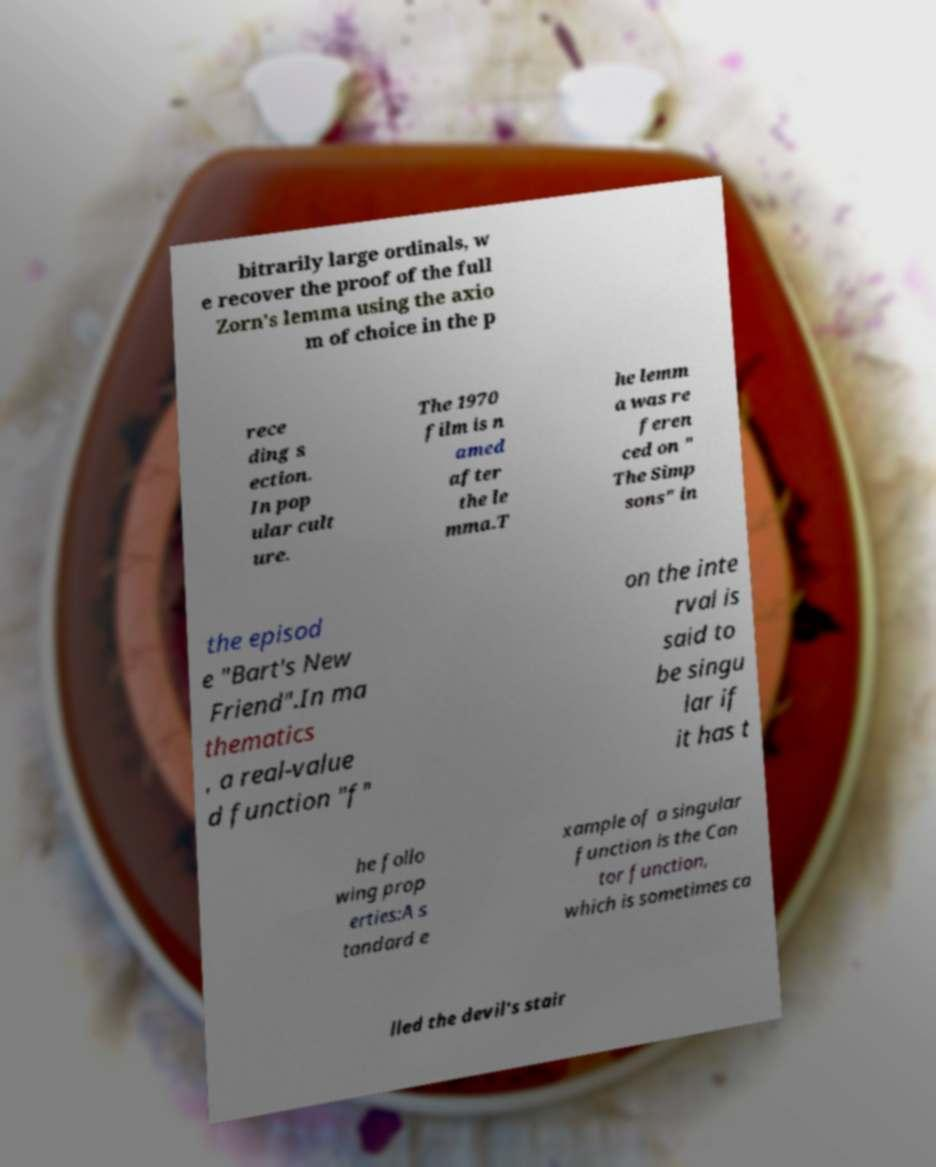Could you extract and type out the text from this image? bitrarily large ordinals, w e recover the proof of the full Zorn's lemma using the axio m of choice in the p rece ding s ection. In pop ular cult ure. The 1970 film is n amed after the le mma.T he lemm a was re feren ced on " The Simp sons" in the episod e "Bart's New Friend".In ma thematics , a real-value d function "f" on the inte rval is said to be singu lar if it has t he follo wing prop erties:A s tandard e xample of a singular function is the Can tor function, which is sometimes ca lled the devil's stair 